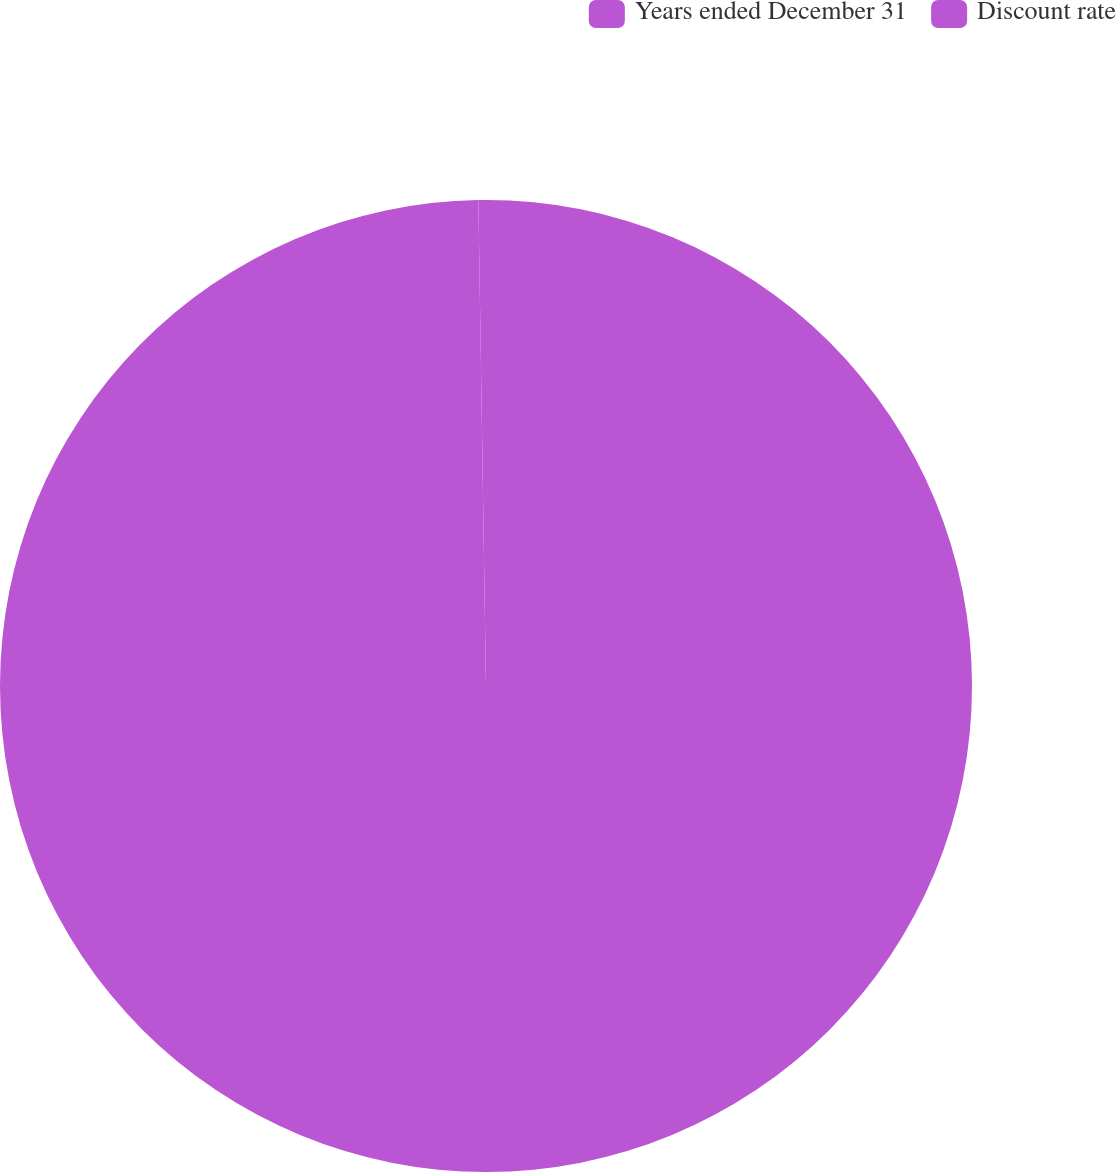<chart> <loc_0><loc_0><loc_500><loc_500><pie_chart><fcel>Years ended December 31<fcel>Discount rate<nl><fcel>99.75%<fcel>0.25%<nl></chart> 